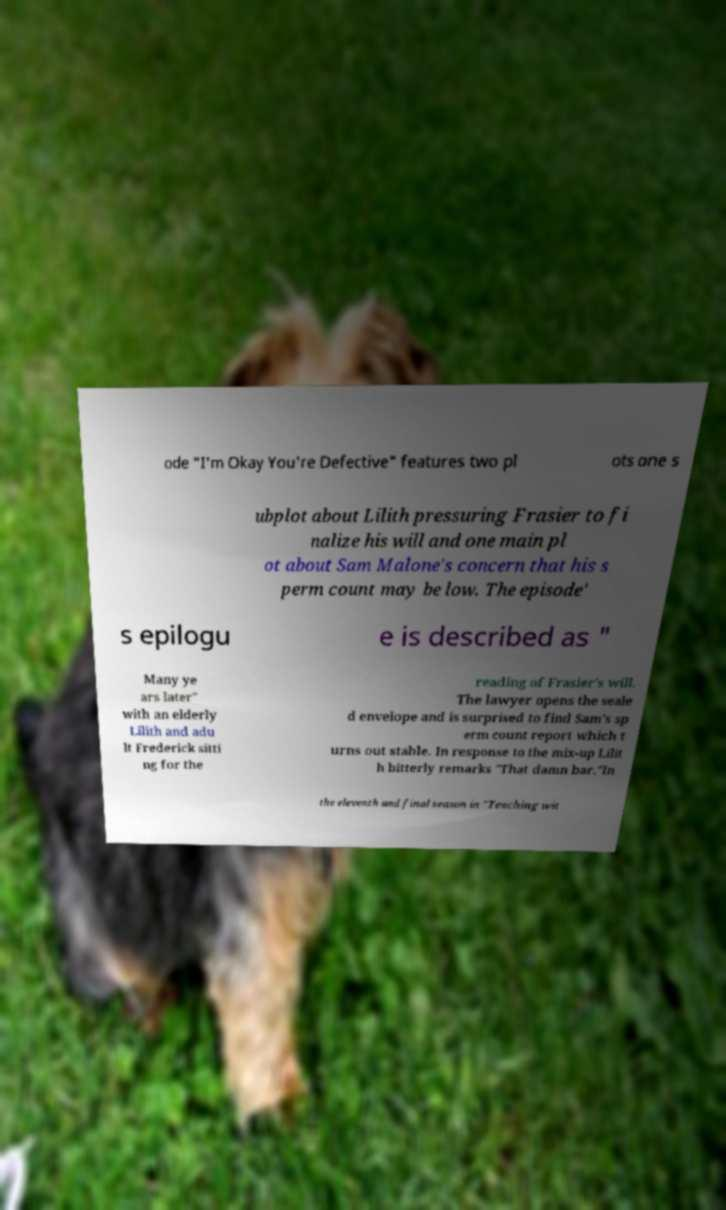What messages or text are displayed in this image? I need them in a readable, typed format. ode "I'm Okay You're Defective" features two pl ots one s ubplot about Lilith pressuring Frasier to fi nalize his will and one main pl ot about Sam Malone's concern that his s perm count may be low. The episode' s epilogu e is described as " Many ye ars later" with an elderly Lilith and adu lt Frederick sitti ng for the reading of Frasier's will. The lawyer opens the seale d envelope and is surprised to find Sam's sp erm count report which t urns out stable. In response to the mix-up Lilit h bitterly remarks "That damn bar."In the eleventh and final season in "Teaching wit 